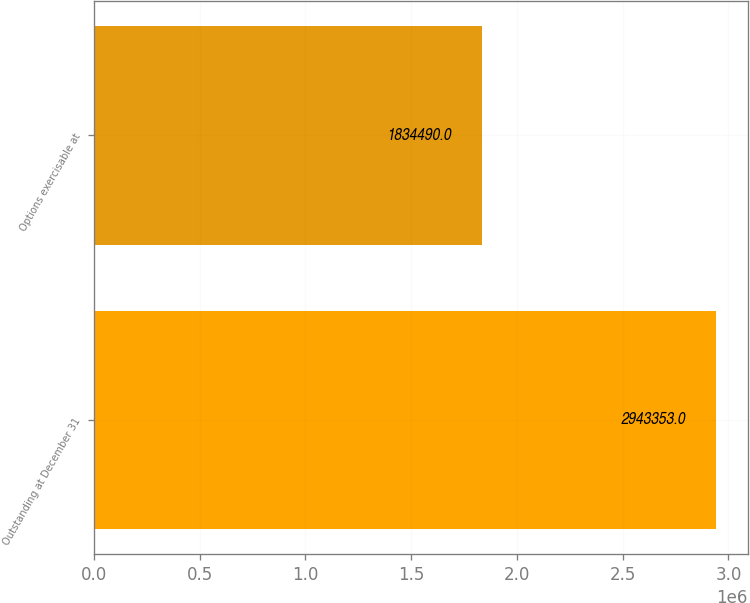Convert chart. <chart><loc_0><loc_0><loc_500><loc_500><bar_chart><fcel>Outstanding at December 31<fcel>Options exercisable at<nl><fcel>2.94335e+06<fcel>1.83449e+06<nl></chart> 